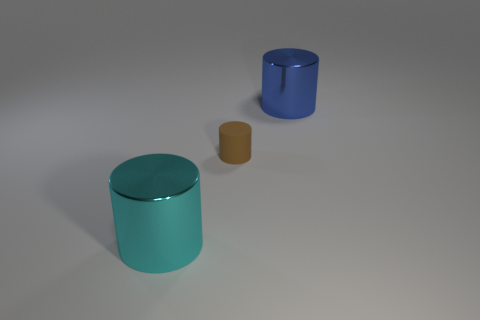Add 1 blue objects. How many objects exist? 4 Add 1 big cyan things. How many big cyan things are left? 2 Add 2 metal things. How many metal things exist? 4 Subtract 0 purple blocks. How many objects are left? 3 Subtract all tiny rubber cylinders. Subtract all large blue metal cylinders. How many objects are left? 1 